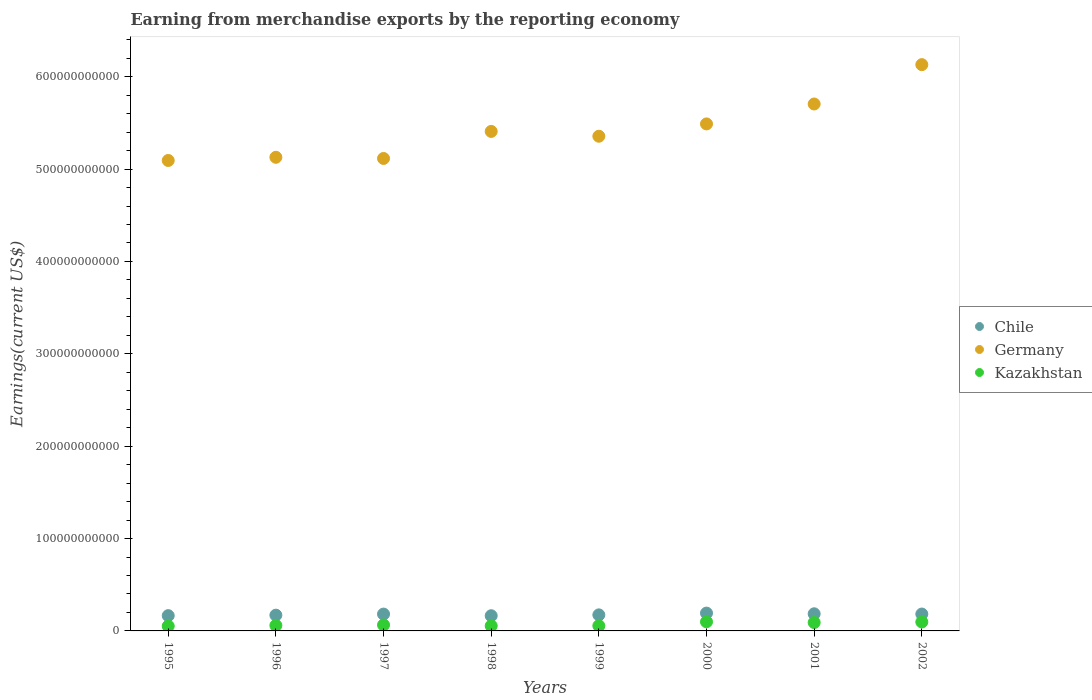How many different coloured dotlines are there?
Your response must be concise. 3. Is the number of dotlines equal to the number of legend labels?
Provide a short and direct response. Yes. What is the amount earned from merchandise exports in Chile in 2001?
Offer a very short reply. 1.86e+1. Across all years, what is the maximum amount earned from merchandise exports in Kazakhstan?
Provide a succinct answer. 9.88e+09. Across all years, what is the minimum amount earned from merchandise exports in Germany?
Give a very brief answer. 5.09e+11. What is the total amount earned from merchandise exports in Kazakhstan in the graph?
Your answer should be very brief. 5.74e+1. What is the difference between the amount earned from merchandise exports in Germany in 1997 and that in 1998?
Ensure brevity in your answer.  -2.93e+1. What is the difference between the amount earned from merchandise exports in Kazakhstan in 1997 and the amount earned from merchandise exports in Chile in 1996?
Provide a succinct answer. -1.06e+1. What is the average amount earned from merchandise exports in Germany per year?
Your answer should be very brief. 5.43e+11. In the year 2002, what is the difference between the amount earned from merchandise exports in Germany and amount earned from merchandise exports in Chile?
Provide a short and direct response. 5.95e+11. What is the ratio of the amount earned from merchandise exports in Kazakhstan in 1996 to that in 1997?
Keep it short and to the point. 0.91. Is the difference between the amount earned from merchandise exports in Germany in 1996 and 2002 greater than the difference between the amount earned from merchandise exports in Chile in 1996 and 2002?
Ensure brevity in your answer.  No. What is the difference between the highest and the second highest amount earned from merchandise exports in Chile?
Your answer should be very brief. 7.41e+08. What is the difference between the highest and the lowest amount earned from merchandise exports in Germany?
Make the answer very short. 1.04e+11. Is the sum of the amount earned from merchandise exports in Chile in 1998 and 2001 greater than the maximum amount earned from merchandise exports in Germany across all years?
Your answer should be compact. No. Is the amount earned from merchandise exports in Chile strictly less than the amount earned from merchandise exports in Kazakhstan over the years?
Your answer should be very brief. No. What is the difference between two consecutive major ticks on the Y-axis?
Offer a very short reply. 1.00e+11. Are the values on the major ticks of Y-axis written in scientific E-notation?
Provide a short and direct response. No. Does the graph contain any zero values?
Your response must be concise. No. Where does the legend appear in the graph?
Offer a very short reply. Center right. How are the legend labels stacked?
Provide a succinct answer. Vertical. What is the title of the graph?
Offer a very short reply. Earning from merchandise exports by the reporting economy. What is the label or title of the Y-axis?
Provide a short and direct response. Earnings(current US$). What is the Earnings(current US$) of Chile in 1995?
Make the answer very short. 1.65e+1. What is the Earnings(current US$) of Germany in 1995?
Provide a succinct answer. 5.09e+11. What is the Earnings(current US$) in Kazakhstan in 1995?
Provide a short and direct response. 5.26e+09. What is the Earnings(current US$) in Chile in 1996?
Offer a terse response. 1.71e+1. What is the Earnings(current US$) of Germany in 1996?
Provide a succinct answer. 5.13e+11. What is the Earnings(current US$) of Kazakhstan in 1996?
Offer a very short reply. 5.93e+09. What is the Earnings(current US$) of Chile in 1997?
Provide a short and direct response. 1.82e+1. What is the Earnings(current US$) of Germany in 1997?
Your response must be concise. 5.11e+11. What is the Earnings(current US$) in Kazakhstan in 1997?
Offer a terse response. 6.50e+09. What is the Earnings(current US$) of Chile in 1998?
Provide a succinct answer. 1.64e+1. What is the Earnings(current US$) of Germany in 1998?
Your answer should be compact. 5.41e+11. What is the Earnings(current US$) in Kazakhstan in 1998?
Give a very brief answer. 5.51e+09. What is the Earnings(current US$) of Chile in 1999?
Your response must be concise. 1.74e+1. What is the Earnings(current US$) in Germany in 1999?
Ensure brevity in your answer.  5.36e+11. What is the Earnings(current US$) of Kazakhstan in 1999?
Provide a short and direct response. 5.60e+09. What is the Earnings(current US$) in Chile in 2000?
Give a very brief answer. 1.93e+1. What is the Earnings(current US$) of Germany in 2000?
Give a very brief answer. 5.49e+11. What is the Earnings(current US$) of Kazakhstan in 2000?
Give a very brief answer. 9.88e+09. What is the Earnings(current US$) of Chile in 2001?
Provide a short and direct response. 1.86e+1. What is the Earnings(current US$) in Germany in 2001?
Offer a very short reply. 5.70e+11. What is the Earnings(current US$) of Kazakhstan in 2001?
Ensure brevity in your answer.  9.09e+09. What is the Earnings(current US$) of Chile in 2002?
Your response must be concise. 1.83e+1. What is the Earnings(current US$) in Germany in 2002?
Offer a terse response. 6.13e+11. What is the Earnings(current US$) of Kazakhstan in 2002?
Offer a terse response. 9.67e+09. Across all years, what is the maximum Earnings(current US$) in Chile?
Your answer should be compact. 1.93e+1. Across all years, what is the maximum Earnings(current US$) of Germany?
Provide a short and direct response. 6.13e+11. Across all years, what is the maximum Earnings(current US$) in Kazakhstan?
Provide a short and direct response. 9.88e+09. Across all years, what is the minimum Earnings(current US$) in Chile?
Keep it short and to the point. 1.64e+1. Across all years, what is the minimum Earnings(current US$) in Germany?
Provide a succinct answer. 5.09e+11. Across all years, what is the minimum Earnings(current US$) in Kazakhstan?
Your answer should be compact. 5.26e+09. What is the total Earnings(current US$) of Chile in the graph?
Your answer should be very brief. 1.42e+11. What is the total Earnings(current US$) of Germany in the graph?
Make the answer very short. 4.34e+12. What is the total Earnings(current US$) of Kazakhstan in the graph?
Keep it short and to the point. 5.74e+1. What is the difference between the Earnings(current US$) in Chile in 1995 and that in 1996?
Make the answer very short. -5.18e+08. What is the difference between the Earnings(current US$) of Germany in 1995 and that in 1996?
Offer a very short reply. -3.45e+09. What is the difference between the Earnings(current US$) in Kazakhstan in 1995 and that in 1996?
Your answer should be compact. -6.70e+08. What is the difference between the Earnings(current US$) in Chile in 1995 and that in 1997?
Your answer should be very brief. -1.68e+09. What is the difference between the Earnings(current US$) in Germany in 1995 and that in 1997?
Your answer should be very brief. -2.18e+09. What is the difference between the Earnings(current US$) of Kazakhstan in 1995 and that in 1997?
Make the answer very short. -1.24e+09. What is the difference between the Earnings(current US$) of Chile in 1995 and that in 1998?
Your answer should be compact. 1.01e+08. What is the difference between the Earnings(current US$) in Germany in 1995 and that in 1998?
Make the answer very short. -3.15e+1. What is the difference between the Earnings(current US$) in Kazakhstan in 1995 and that in 1998?
Give a very brief answer. -2.54e+08. What is the difference between the Earnings(current US$) of Chile in 1995 and that in 1999?
Your answer should be very brief. -8.31e+08. What is the difference between the Earnings(current US$) in Germany in 1995 and that in 1999?
Give a very brief answer. -2.63e+1. What is the difference between the Earnings(current US$) of Kazakhstan in 1995 and that in 1999?
Your answer should be compact. -3.41e+08. What is the difference between the Earnings(current US$) in Chile in 1995 and that in 2000?
Your answer should be compact. -2.75e+09. What is the difference between the Earnings(current US$) of Germany in 1995 and that in 2000?
Ensure brevity in your answer.  -3.96e+1. What is the difference between the Earnings(current US$) in Kazakhstan in 1995 and that in 2000?
Your answer should be compact. -4.62e+09. What is the difference between the Earnings(current US$) in Chile in 1995 and that in 2001?
Offer a terse response. -2.01e+09. What is the difference between the Earnings(current US$) in Germany in 1995 and that in 2001?
Give a very brief answer. -6.11e+1. What is the difference between the Earnings(current US$) of Kazakhstan in 1995 and that in 2001?
Make the answer very short. -3.83e+09. What is the difference between the Earnings(current US$) in Chile in 1995 and that in 2002?
Your response must be concise. -1.74e+09. What is the difference between the Earnings(current US$) in Germany in 1995 and that in 2002?
Your answer should be compact. -1.04e+11. What is the difference between the Earnings(current US$) of Kazakhstan in 1995 and that in 2002?
Provide a succinct answer. -4.41e+09. What is the difference between the Earnings(current US$) of Chile in 1996 and that in 1997?
Keep it short and to the point. -1.16e+09. What is the difference between the Earnings(current US$) of Germany in 1996 and that in 1997?
Your answer should be very brief. 1.27e+09. What is the difference between the Earnings(current US$) in Kazakhstan in 1996 and that in 1997?
Keep it short and to the point. -5.71e+08. What is the difference between the Earnings(current US$) of Chile in 1996 and that in 1998?
Provide a succinct answer. 6.20e+08. What is the difference between the Earnings(current US$) in Germany in 1996 and that in 1998?
Keep it short and to the point. -2.80e+1. What is the difference between the Earnings(current US$) of Kazakhstan in 1996 and that in 1998?
Provide a short and direct response. 4.16e+08. What is the difference between the Earnings(current US$) in Chile in 1996 and that in 1999?
Your response must be concise. -3.13e+08. What is the difference between the Earnings(current US$) of Germany in 1996 and that in 1999?
Provide a short and direct response. -2.28e+1. What is the difference between the Earnings(current US$) of Kazakhstan in 1996 and that in 1999?
Your answer should be compact. 3.28e+08. What is the difference between the Earnings(current US$) in Chile in 1996 and that in 2000?
Provide a succinct answer. -2.23e+09. What is the difference between the Earnings(current US$) of Germany in 1996 and that in 2000?
Offer a very short reply. -3.61e+1. What is the difference between the Earnings(current US$) of Kazakhstan in 1996 and that in 2000?
Provide a short and direct response. -3.95e+09. What is the difference between the Earnings(current US$) in Chile in 1996 and that in 2001?
Offer a terse response. -1.49e+09. What is the difference between the Earnings(current US$) in Germany in 1996 and that in 2001?
Keep it short and to the point. -5.77e+1. What is the difference between the Earnings(current US$) of Kazakhstan in 1996 and that in 2001?
Offer a very short reply. -3.16e+09. What is the difference between the Earnings(current US$) of Chile in 1996 and that in 2002?
Keep it short and to the point. -1.22e+09. What is the difference between the Earnings(current US$) in Germany in 1996 and that in 2002?
Offer a very short reply. -1.00e+11. What is the difference between the Earnings(current US$) in Kazakhstan in 1996 and that in 2002?
Provide a succinct answer. -3.74e+09. What is the difference between the Earnings(current US$) in Chile in 1997 and that in 1998?
Provide a succinct answer. 1.78e+09. What is the difference between the Earnings(current US$) in Germany in 1997 and that in 1998?
Make the answer very short. -2.93e+1. What is the difference between the Earnings(current US$) of Kazakhstan in 1997 and that in 1998?
Make the answer very short. 9.87e+08. What is the difference between the Earnings(current US$) of Chile in 1997 and that in 1999?
Offer a very short reply. 8.47e+08. What is the difference between the Earnings(current US$) in Germany in 1997 and that in 1999?
Offer a very short reply. -2.41e+1. What is the difference between the Earnings(current US$) in Kazakhstan in 1997 and that in 1999?
Keep it short and to the point. 8.99e+08. What is the difference between the Earnings(current US$) of Chile in 1997 and that in 2000?
Offer a terse response. -1.07e+09. What is the difference between the Earnings(current US$) of Germany in 1997 and that in 2000?
Your answer should be compact. -3.74e+1. What is the difference between the Earnings(current US$) of Kazakhstan in 1997 and that in 2000?
Offer a terse response. -3.38e+09. What is the difference between the Earnings(current US$) of Chile in 1997 and that in 2001?
Your answer should be very brief. -3.32e+08. What is the difference between the Earnings(current US$) in Germany in 1997 and that in 2001?
Give a very brief answer. -5.90e+1. What is the difference between the Earnings(current US$) of Kazakhstan in 1997 and that in 2001?
Provide a short and direct response. -2.59e+09. What is the difference between the Earnings(current US$) in Chile in 1997 and that in 2002?
Provide a succinct answer. -6.26e+07. What is the difference between the Earnings(current US$) of Germany in 1997 and that in 2002?
Provide a succinct answer. -1.02e+11. What is the difference between the Earnings(current US$) in Kazakhstan in 1997 and that in 2002?
Your answer should be compact. -3.17e+09. What is the difference between the Earnings(current US$) of Chile in 1998 and that in 1999?
Provide a succinct answer. -9.33e+08. What is the difference between the Earnings(current US$) in Germany in 1998 and that in 1999?
Ensure brevity in your answer.  5.21e+09. What is the difference between the Earnings(current US$) in Kazakhstan in 1998 and that in 1999?
Your answer should be very brief. -8.72e+07. What is the difference between the Earnings(current US$) of Chile in 1998 and that in 2000?
Ensure brevity in your answer.  -2.85e+09. What is the difference between the Earnings(current US$) of Germany in 1998 and that in 2000?
Your response must be concise. -8.13e+09. What is the difference between the Earnings(current US$) in Kazakhstan in 1998 and that in 2000?
Your answer should be very brief. -4.37e+09. What is the difference between the Earnings(current US$) in Chile in 1998 and that in 2001?
Ensure brevity in your answer.  -2.11e+09. What is the difference between the Earnings(current US$) in Germany in 1998 and that in 2001?
Ensure brevity in your answer.  -2.97e+1. What is the difference between the Earnings(current US$) in Kazakhstan in 1998 and that in 2001?
Your response must be concise. -3.57e+09. What is the difference between the Earnings(current US$) of Chile in 1998 and that in 2002?
Provide a short and direct response. -1.84e+09. What is the difference between the Earnings(current US$) in Germany in 1998 and that in 2002?
Your response must be concise. -7.23e+1. What is the difference between the Earnings(current US$) of Kazakhstan in 1998 and that in 2002?
Give a very brief answer. -4.16e+09. What is the difference between the Earnings(current US$) of Chile in 1999 and that in 2000?
Your response must be concise. -1.92e+09. What is the difference between the Earnings(current US$) in Germany in 1999 and that in 2000?
Your answer should be compact. -1.33e+1. What is the difference between the Earnings(current US$) of Kazakhstan in 1999 and that in 2000?
Your answer should be compact. -4.28e+09. What is the difference between the Earnings(current US$) of Chile in 1999 and that in 2001?
Keep it short and to the point. -1.18e+09. What is the difference between the Earnings(current US$) of Germany in 1999 and that in 2001?
Provide a succinct answer. -3.49e+1. What is the difference between the Earnings(current US$) in Kazakhstan in 1999 and that in 2001?
Your response must be concise. -3.49e+09. What is the difference between the Earnings(current US$) of Chile in 1999 and that in 2002?
Ensure brevity in your answer.  -9.09e+08. What is the difference between the Earnings(current US$) of Germany in 1999 and that in 2002?
Provide a short and direct response. -7.75e+1. What is the difference between the Earnings(current US$) in Kazakhstan in 1999 and that in 2002?
Provide a succinct answer. -4.07e+09. What is the difference between the Earnings(current US$) in Chile in 2000 and that in 2001?
Give a very brief answer. 7.41e+08. What is the difference between the Earnings(current US$) in Germany in 2000 and that in 2001?
Offer a terse response. -2.16e+1. What is the difference between the Earnings(current US$) in Kazakhstan in 2000 and that in 2001?
Make the answer very short. 7.95e+08. What is the difference between the Earnings(current US$) in Chile in 2000 and that in 2002?
Make the answer very short. 1.01e+09. What is the difference between the Earnings(current US$) in Germany in 2000 and that in 2002?
Ensure brevity in your answer.  -6.42e+1. What is the difference between the Earnings(current US$) in Kazakhstan in 2000 and that in 2002?
Provide a short and direct response. 2.09e+08. What is the difference between the Earnings(current US$) in Chile in 2001 and that in 2002?
Offer a very short reply. 2.69e+08. What is the difference between the Earnings(current US$) of Germany in 2001 and that in 2002?
Give a very brief answer. -4.26e+1. What is the difference between the Earnings(current US$) in Kazakhstan in 2001 and that in 2002?
Your answer should be very brief. -5.85e+08. What is the difference between the Earnings(current US$) of Chile in 1995 and the Earnings(current US$) of Germany in 1996?
Keep it short and to the point. -4.96e+11. What is the difference between the Earnings(current US$) in Chile in 1995 and the Earnings(current US$) in Kazakhstan in 1996?
Ensure brevity in your answer.  1.06e+1. What is the difference between the Earnings(current US$) in Germany in 1995 and the Earnings(current US$) in Kazakhstan in 1996?
Provide a short and direct response. 5.03e+11. What is the difference between the Earnings(current US$) of Chile in 1995 and the Earnings(current US$) of Germany in 1997?
Your answer should be very brief. -4.95e+11. What is the difference between the Earnings(current US$) of Chile in 1995 and the Earnings(current US$) of Kazakhstan in 1997?
Offer a terse response. 1.00e+1. What is the difference between the Earnings(current US$) in Germany in 1995 and the Earnings(current US$) in Kazakhstan in 1997?
Provide a short and direct response. 5.03e+11. What is the difference between the Earnings(current US$) of Chile in 1995 and the Earnings(current US$) of Germany in 1998?
Offer a terse response. -5.24e+11. What is the difference between the Earnings(current US$) in Chile in 1995 and the Earnings(current US$) in Kazakhstan in 1998?
Offer a very short reply. 1.10e+1. What is the difference between the Earnings(current US$) of Germany in 1995 and the Earnings(current US$) of Kazakhstan in 1998?
Your answer should be very brief. 5.04e+11. What is the difference between the Earnings(current US$) in Chile in 1995 and the Earnings(current US$) in Germany in 1999?
Offer a very short reply. -5.19e+11. What is the difference between the Earnings(current US$) of Chile in 1995 and the Earnings(current US$) of Kazakhstan in 1999?
Provide a succinct answer. 1.09e+1. What is the difference between the Earnings(current US$) in Germany in 1995 and the Earnings(current US$) in Kazakhstan in 1999?
Make the answer very short. 5.04e+11. What is the difference between the Earnings(current US$) in Chile in 1995 and the Earnings(current US$) in Germany in 2000?
Your answer should be compact. -5.32e+11. What is the difference between the Earnings(current US$) in Chile in 1995 and the Earnings(current US$) in Kazakhstan in 2000?
Make the answer very short. 6.66e+09. What is the difference between the Earnings(current US$) in Germany in 1995 and the Earnings(current US$) in Kazakhstan in 2000?
Ensure brevity in your answer.  4.99e+11. What is the difference between the Earnings(current US$) of Chile in 1995 and the Earnings(current US$) of Germany in 2001?
Provide a succinct answer. -5.54e+11. What is the difference between the Earnings(current US$) of Chile in 1995 and the Earnings(current US$) of Kazakhstan in 2001?
Make the answer very short. 7.46e+09. What is the difference between the Earnings(current US$) in Germany in 1995 and the Earnings(current US$) in Kazakhstan in 2001?
Give a very brief answer. 5.00e+11. What is the difference between the Earnings(current US$) in Chile in 1995 and the Earnings(current US$) in Germany in 2002?
Your response must be concise. -5.97e+11. What is the difference between the Earnings(current US$) of Chile in 1995 and the Earnings(current US$) of Kazakhstan in 2002?
Keep it short and to the point. 6.87e+09. What is the difference between the Earnings(current US$) of Germany in 1995 and the Earnings(current US$) of Kazakhstan in 2002?
Your answer should be very brief. 5.00e+11. What is the difference between the Earnings(current US$) in Chile in 1996 and the Earnings(current US$) in Germany in 1997?
Provide a short and direct response. -4.94e+11. What is the difference between the Earnings(current US$) in Chile in 1996 and the Earnings(current US$) in Kazakhstan in 1997?
Offer a terse response. 1.06e+1. What is the difference between the Earnings(current US$) in Germany in 1996 and the Earnings(current US$) in Kazakhstan in 1997?
Give a very brief answer. 5.06e+11. What is the difference between the Earnings(current US$) in Chile in 1996 and the Earnings(current US$) in Germany in 1998?
Keep it short and to the point. -5.24e+11. What is the difference between the Earnings(current US$) of Chile in 1996 and the Earnings(current US$) of Kazakhstan in 1998?
Make the answer very short. 1.16e+1. What is the difference between the Earnings(current US$) of Germany in 1996 and the Earnings(current US$) of Kazakhstan in 1998?
Ensure brevity in your answer.  5.07e+11. What is the difference between the Earnings(current US$) in Chile in 1996 and the Earnings(current US$) in Germany in 1999?
Your response must be concise. -5.18e+11. What is the difference between the Earnings(current US$) in Chile in 1996 and the Earnings(current US$) in Kazakhstan in 1999?
Ensure brevity in your answer.  1.15e+1. What is the difference between the Earnings(current US$) of Germany in 1996 and the Earnings(current US$) of Kazakhstan in 1999?
Offer a terse response. 5.07e+11. What is the difference between the Earnings(current US$) in Chile in 1996 and the Earnings(current US$) in Germany in 2000?
Keep it short and to the point. -5.32e+11. What is the difference between the Earnings(current US$) in Chile in 1996 and the Earnings(current US$) in Kazakhstan in 2000?
Make the answer very short. 7.18e+09. What is the difference between the Earnings(current US$) in Germany in 1996 and the Earnings(current US$) in Kazakhstan in 2000?
Your answer should be compact. 5.03e+11. What is the difference between the Earnings(current US$) in Chile in 1996 and the Earnings(current US$) in Germany in 2001?
Make the answer very short. -5.53e+11. What is the difference between the Earnings(current US$) in Chile in 1996 and the Earnings(current US$) in Kazakhstan in 2001?
Offer a terse response. 7.98e+09. What is the difference between the Earnings(current US$) of Germany in 1996 and the Earnings(current US$) of Kazakhstan in 2001?
Ensure brevity in your answer.  5.04e+11. What is the difference between the Earnings(current US$) in Chile in 1996 and the Earnings(current US$) in Germany in 2002?
Provide a succinct answer. -5.96e+11. What is the difference between the Earnings(current US$) in Chile in 1996 and the Earnings(current US$) in Kazakhstan in 2002?
Your response must be concise. 7.39e+09. What is the difference between the Earnings(current US$) in Germany in 1996 and the Earnings(current US$) in Kazakhstan in 2002?
Offer a terse response. 5.03e+11. What is the difference between the Earnings(current US$) of Chile in 1997 and the Earnings(current US$) of Germany in 1998?
Offer a terse response. -5.23e+11. What is the difference between the Earnings(current US$) of Chile in 1997 and the Earnings(current US$) of Kazakhstan in 1998?
Provide a short and direct response. 1.27e+1. What is the difference between the Earnings(current US$) of Germany in 1997 and the Earnings(current US$) of Kazakhstan in 1998?
Offer a very short reply. 5.06e+11. What is the difference between the Earnings(current US$) in Chile in 1997 and the Earnings(current US$) in Germany in 1999?
Provide a succinct answer. -5.17e+11. What is the difference between the Earnings(current US$) in Chile in 1997 and the Earnings(current US$) in Kazakhstan in 1999?
Your answer should be compact. 1.26e+1. What is the difference between the Earnings(current US$) of Germany in 1997 and the Earnings(current US$) of Kazakhstan in 1999?
Offer a very short reply. 5.06e+11. What is the difference between the Earnings(current US$) of Chile in 1997 and the Earnings(current US$) of Germany in 2000?
Keep it short and to the point. -5.31e+11. What is the difference between the Earnings(current US$) in Chile in 1997 and the Earnings(current US$) in Kazakhstan in 2000?
Your answer should be compact. 8.34e+09. What is the difference between the Earnings(current US$) of Germany in 1997 and the Earnings(current US$) of Kazakhstan in 2000?
Keep it short and to the point. 5.02e+11. What is the difference between the Earnings(current US$) of Chile in 1997 and the Earnings(current US$) of Germany in 2001?
Provide a short and direct response. -5.52e+11. What is the difference between the Earnings(current US$) in Chile in 1997 and the Earnings(current US$) in Kazakhstan in 2001?
Provide a short and direct response. 9.14e+09. What is the difference between the Earnings(current US$) in Germany in 1997 and the Earnings(current US$) in Kazakhstan in 2001?
Provide a short and direct response. 5.02e+11. What is the difference between the Earnings(current US$) of Chile in 1997 and the Earnings(current US$) of Germany in 2002?
Make the answer very short. -5.95e+11. What is the difference between the Earnings(current US$) of Chile in 1997 and the Earnings(current US$) of Kazakhstan in 2002?
Your answer should be very brief. 8.55e+09. What is the difference between the Earnings(current US$) in Germany in 1997 and the Earnings(current US$) in Kazakhstan in 2002?
Make the answer very short. 5.02e+11. What is the difference between the Earnings(current US$) of Chile in 1998 and the Earnings(current US$) of Germany in 1999?
Provide a short and direct response. -5.19e+11. What is the difference between the Earnings(current US$) of Chile in 1998 and the Earnings(current US$) of Kazakhstan in 1999?
Make the answer very short. 1.08e+1. What is the difference between the Earnings(current US$) of Germany in 1998 and the Earnings(current US$) of Kazakhstan in 1999?
Provide a short and direct response. 5.35e+11. What is the difference between the Earnings(current US$) of Chile in 1998 and the Earnings(current US$) of Germany in 2000?
Provide a short and direct response. -5.32e+11. What is the difference between the Earnings(current US$) in Chile in 1998 and the Earnings(current US$) in Kazakhstan in 2000?
Your answer should be very brief. 6.56e+09. What is the difference between the Earnings(current US$) in Germany in 1998 and the Earnings(current US$) in Kazakhstan in 2000?
Keep it short and to the point. 5.31e+11. What is the difference between the Earnings(current US$) of Chile in 1998 and the Earnings(current US$) of Germany in 2001?
Keep it short and to the point. -5.54e+11. What is the difference between the Earnings(current US$) of Chile in 1998 and the Earnings(current US$) of Kazakhstan in 2001?
Keep it short and to the point. 7.36e+09. What is the difference between the Earnings(current US$) in Germany in 1998 and the Earnings(current US$) in Kazakhstan in 2001?
Keep it short and to the point. 5.32e+11. What is the difference between the Earnings(current US$) in Chile in 1998 and the Earnings(current US$) in Germany in 2002?
Offer a very short reply. -5.97e+11. What is the difference between the Earnings(current US$) in Chile in 1998 and the Earnings(current US$) in Kazakhstan in 2002?
Ensure brevity in your answer.  6.77e+09. What is the difference between the Earnings(current US$) in Germany in 1998 and the Earnings(current US$) in Kazakhstan in 2002?
Keep it short and to the point. 5.31e+11. What is the difference between the Earnings(current US$) in Chile in 1999 and the Earnings(current US$) in Germany in 2000?
Ensure brevity in your answer.  -5.32e+11. What is the difference between the Earnings(current US$) in Chile in 1999 and the Earnings(current US$) in Kazakhstan in 2000?
Give a very brief answer. 7.50e+09. What is the difference between the Earnings(current US$) of Germany in 1999 and the Earnings(current US$) of Kazakhstan in 2000?
Offer a terse response. 5.26e+11. What is the difference between the Earnings(current US$) of Chile in 1999 and the Earnings(current US$) of Germany in 2001?
Provide a succinct answer. -5.53e+11. What is the difference between the Earnings(current US$) of Chile in 1999 and the Earnings(current US$) of Kazakhstan in 2001?
Make the answer very short. 8.29e+09. What is the difference between the Earnings(current US$) of Germany in 1999 and the Earnings(current US$) of Kazakhstan in 2001?
Ensure brevity in your answer.  5.26e+11. What is the difference between the Earnings(current US$) of Chile in 1999 and the Earnings(current US$) of Germany in 2002?
Provide a succinct answer. -5.96e+11. What is the difference between the Earnings(current US$) of Chile in 1999 and the Earnings(current US$) of Kazakhstan in 2002?
Your answer should be compact. 7.71e+09. What is the difference between the Earnings(current US$) in Germany in 1999 and the Earnings(current US$) in Kazakhstan in 2002?
Make the answer very short. 5.26e+11. What is the difference between the Earnings(current US$) in Chile in 2000 and the Earnings(current US$) in Germany in 2001?
Ensure brevity in your answer.  -5.51e+11. What is the difference between the Earnings(current US$) in Chile in 2000 and the Earnings(current US$) in Kazakhstan in 2001?
Provide a succinct answer. 1.02e+1. What is the difference between the Earnings(current US$) in Germany in 2000 and the Earnings(current US$) in Kazakhstan in 2001?
Make the answer very short. 5.40e+11. What is the difference between the Earnings(current US$) in Chile in 2000 and the Earnings(current US$) in Germany in 2002?
Give a very brief answer. -5.94e+11. What is the difference between the Earnings(current US$) of Chile in 2000 and the Earnings(current US$) of Kazakhstan in 2002?
Offer a very short reply. 9.63e+09. What is the difference between the Earnings(current US$) in Germany in 2000 and the Earnings(current US$) in Kazakhstan in 2002?
Offer a very short reply. 5.39e+11. What is the difference between the Earnings(current US$) in Chile in 2001 and the Earnings(current US$) in Germany in 2002?
Offer a terse response. -5.95e+11. What is the difference between the Earnings(current US$) of Chile in 2001 and the Earnings(current US$) of Kazakhstan in 2002?
Your answer should be compact. 8.88e+09. What is the difference between the Earnings(current US$) of Germany in 2001 and the Earnings(current US$) of Kazakhstan in 2002?
Make the answer very short. 5.61e+11. What is the average Earnings(current US$) of Chile per year?
Keep it short and to the point. 1.77e+1. What is the average Earnings(current US$) of Germany per year?
Your response must be concise. 5.43e+11. What is the average Earnings(current US$) of Kazakhstan per year?
Provide a succinct answer. 7.18e+09. In the year 1995, what is the difference between the Earnings(current US$) of Chile and Earnings(current US$) of Germany?
Your answer should be very brief. -4.93e+11. In the year 1995, what is the difference between the Earnings(current US$) of Chile and Earnings(current US$) of Kazakhstan?
Offer a very short reply. 1.13e+1. In the year 1995, what is the difference between the Earnings(current US$) in Germany and Earnings(current US$) in Kazakhstan?
Your answer should be compact. 5.04e+11. In the year 1996, what is the difference between the Earnings(current US$) of Chile and Earnings(current US$) of Germany?
Provide a succinct answer. -4.96e+11. In the year 1996, what is the difference between the Earnings(current US$) in Chile and Earnings(current US$) in Kazakhstan?
Your response must be concise. 1.11e+1. In the year 1996, what is the difference between the Earnings(current US$) of Germany and Earnings(current US$) of Kazakhstan?
Provide a short and direct response. 5.07e+11. In the year 1997, what is the difference between the Earnings(current US$) in Chile and Earnings(current US$) in Germany?
Your response must be concise. -4.93e+11. In the year 1997, what is the difference between the Earnings(current US$) of Chile and Earnings(current US$) of Kazakhstan?
Your answer should be very brief. 1.17e+1. In the year 1997, what is the difference between the Earnings(current US$) of Germany and Earnings(current US$) of Kazakhstan?
Your response must be concise. 5.05e+11. In the year 1998, what is the difference between the Earnings(current US$) of Chile and Earnings(current US$) of Germany?
Offer a very short reply. -5.24e+11. In the year 1998, what is the difference between the Earnings(current US$) in Chile and Earnings(current US$) in Kazakhstan?
Offer a terse response. 1.09e+1. In the year 1998, what is the difference between the Earnings(current US$) in Germany and Earnings(current US$) in Kazakhstan?
Keep it short and to the point. 5.35e+11. In the year 1999, what is the difference between the Earnings(current US$) in Chile and Earnings(current US$) in Germany?
Give a very brief answer. -5.18e+11. In the year 1999, what is the difference between the Earnings(current US$) of Chile and Earnings(current US$) of Kazakhstan?
Your answer should be compact. 1.18e+1. In the year 1999, what is the difference between the Earnings(current US$) of Germany and Earnings(current US$) of Kazakhstan?
Give a very brief answer. 5.30e+11. In the year 2000, what is the difference between the Earnings(current US$) of Chile and Earnings(current US$) of Germany?
Your answer should be compact. -5.30e+11. In the year 2000, what is the difference between the Earnings(current US$) of Chile and Earnings(current US$) of Kazakhstan?
Provide a succinct answer. 9.42e+09. In the year 2000, what is the difference between the Earnings(current US$) of Germany and Earnings(current US$) of Kazakhstan?
Your response must be concise. 5.39e+11. In the year 2001, what is the difference between the Earnings(current US$) of Chile and Earnings(current US$) of Germany?
Your answer should be very brief. -5.52e+11. In the year 2001, what is the difference between the Earnings(current US$) of Chile and Earnings(current US$) of Kazakhstan?
Provide a succinct answer. 9.47e+09. In the year 2001, what is the difference between the Earnings(current US$) of Germany and Earnings(current US$) of Kazakhstan?
Provide a succinct answer. 5.61e+11. In the year 2002, what is the difference between the Earnings(current US$) in Chile and Earnings(current US$) in Germany?
Keep it short and to the point. -5.95e+11. In the year 2002, what is the difference between the Earnings(current US$) of Chile and Earnings(current US$) of Kazakhstan?
Keep it short and to the point. 8.61e+09. In the year 2002, what is the difference between the Earnings(current US$) of Germany and Earnings(current US$) of Kazakhstan?
Offer a very short reply. 6.03e+11. What is the ratio of the Earnings(current US$) of Chile in 1995 to that in 1996?
Provide a succinct answer. 0.97. What is the ratio of the Earnings(current US$) in Germany in 1995 to that in 1996?
Ensure brevity in your answer.  0.99. What is the ratio of the Earnings(current US$) in Kazakhstan in 1995 to that in 1996?
Your answer should be very brief. 0.89. What is the ratio of the Earnings(current US$) in Chile in 1995 to that in 1997?
Provide a short and direct response. 0.91. What is the ratio of the Earnings(current US$) in Kazakhstan in 1995 to that in 1997?
Provide a short and direct response. 0.81. What is the ratio of the Earnings(current US$) of Chile in 1995 to that in 1998?
Offer a very short reply. 1.01. What is the ratio of the Earnings(current US$) of Germany in 1995 to that in 1998?
Provide a short and direct response. 0.94. What is the ratio of the Earnings(current US$) in Kazakhstan in 1995 to that in 1998?
Provide a succinct answer. 0.95. What is the ratio of the Earnings(current US$) in Chile in 1995 to that in 1999?
Your answer should be very brief. 0.95. What is the ratio of the Earnings(current US$) in Germany in 1995 to that in 1999?
Provide a succinct answer. 0.95. What is the ratio of the Earnings(current US$) in Kazakhstan in 1995 to that in 1999?
Keep it short and to the point. 0.94. What is the ratio of the Earnings(current US$) of Chile in 1995 to that in 2000?
Offer a terse response. 0.86. What is the ratio of the Earnings(current US$) of Germany in 1995 to that in 2000?
Your answer should be very brief. 0.93. What is the ratio of the Earnings(current US$) of Kazakhstan in 1995 to that in 2000?
Give a very brief answer. 0.53. What is the ratio of the Earnings(current US$) of Chile in 1995 to that in 2001?
Your answer should be compact. 0.89. What is the ratio of the Earnings(current US$) of Germany in 1995 to that in 2001?
Offer a terse response. 0.89. What is the ratio of the Earnings(current US$) of Kazakhstan in 1995 to that in 2001?
Give a very brief answer. 0.58. What is the ratio of the Earnings(current US$) of Chile in 1995 to that in 2002?
Ensure brevity in your answer.  0.9. What is the ratio of the Earnings(current US$) in Germany in 1995 to that in 2002?
Offer a terse response. 0.83. What is the ratio of the Earnings(current US$) of Kazakhstan in 1995 to that in 2002?
Your answer should be very brief. 0.54. What is the ratio of the Earnings(current US$) in Chile in 1996 to that in 1997?
Give a very brief answer. 0.94. What is the ratio of the Earnings(current US$) in Kazakhstan in 1996 to that in 1997?
Your response must be concise. 0.91. What is the ratio of the Earnings(current US$) in Chile in 1996 to that in 1998?
Give a very brief answer. 1.04. What is the ratio of the Earnings(current US$) in Germany in 1996 to that in 1998?
Make the answer very short. 0.95. What is the ratio of the Earnings(current US$) in Kazakhstan in 1996 to that in 1998?
Offer a very short reply. 1.08. What is the ratio of the Earnings(current US$) of Germany in 1996 to that in 1999?
Your answer should be very brief. 0.96. What is the ratio of the Earnings(current US$) of Kazakhstan in 1996 to that in 1999?
Your answer should be compact. 1.06. What is the ratio of the Earnings(current US$) of Chile in 1996 to that in 2000?
Ensure brevity in your answer.  0.88. What is the ratio of the Earnings(current US$) in Germany in 1996 to that in 2000?
Offer a very short reply. 0.93. What is the ratio of the Earnings(current US$) in Kazakhstan in 1996 to that in 2000?
Provide a succinct answer. 0.6. What is the ratio of the Earnings(current US$) in Chile in 1996 to that in 2001?
Provide a short and direct response. 0.92. What is the ratio of the Earnings(current US$) of Germany in 1996 to that in 2001?
Give a very brief answer. 0.9. What is the ratio of the Earnings(current US$) of Kazakhstan in 1996 to that in 2001?
Offer a terse response. 0.65. What is the ratio of the Earnings(current US$) in Chile in 1996 to that in 2002?
Make the answer very short. 0.93. What is the ratio of the Earnings(current US$) in Germany in 1996 to that in 2002?
Your answer should be very brief. 0.84. What is the ratio of the Earnings(current US$) of Kazakhstan in 1996 to that in 2002?
Make the answer very short. 0.61. What is the ratio of the Earnings(current US$) of Chile in 1997 to that in 1998?
Your answer should be compact. 1.11. What is the ratio of the Earnings(current US$) in Germany in 1997 to that in 1998?
Ensure brevity in your answer.  0.95. What is the ratio of the Earnings(current US$) of Kazakhstan in 1997 to that in 1998?
Provide a short and direct response. 1.18. What is the ratio of the Earnings(current US$) of Chile in 1997 to that in 1999?
Ensure brevity in your answer.  1.05. What is the ratio of the Earnings(current US$) in Germany in 1997 to that in 1999?
Your answer should be compact. 0.96. What is the ratio of the Earnings(current US$) in Kazakhstan in 1997 to that in 1999?
Keep it short and to the point. 1.16. What is the ratio of the Earnings(current US$) in Chile in 1997 to that in 2000?
Your response must be concise. 0.94. What is the ratio of the Earnings(current US$) of Germany in 1997 to that in 2000?
Your answer should be compact. 0.93. What is the ratio of the Earnings(current US$) in Kazakhstan in 1997 to that in 2000?
Your answer should be very brief. 0.66. What is the ratio of the Earnings(current US$) in Chile in 1997 to that in 2001?
Keep it short and to the point. 0.98. What is the ratio of the Earnings(current US$) of Germany in 1997 to that in 2001?
Your answer should be very brief. 0.9. What is the ratio of the Earnings(current US$) in Kazakhstan in 1997 to that in 2001?
Your answer should be very brief. 0.72. What is the ratio of the Earnings(current US$) in Chile in 1997 to that in 2002?
Ensure brevity in your answer.  1. What is the ratio of the Earnings(current US$) of Germany in 1997 to that in 2002?
Make the answer very short. 0.83. What is the ratio of the Earnings(current US$) in Kazakhstan in 1997 to that in 2002?
Provide a short and direct response. 0.67. What is the ratio of the Earnings(current US$) in Chile in 1998 to that in 1999?
Give a very brief answer. 0.95. What is the ratio of the Earnings(current US$) of Germany in 1998 to that in 1999?
Provide a succinct answer. 1.01. What is the ratio of the Earnings(current US$) of Kazakhstan in 1998 to that in 1999?
Provide a succinct answer. 0.98. What is the ratio of the Earnings(current US$) of Chile in 1998 to that in 2000?
Offer a very short reply. 0.85. What is the ratio of the Earnings(current US$) of Germany in 1998 to that in 2000?
Provide a succinct answer. 0.99. What is the ratio of the Earnings(current US$) of Kazakhstan in 1998 to that in 2000?
Ensure brevity in your answer.  0.56. What is the ratio of the Earnings(current US$) of Chile in 1998 to that in 2001?
Your answer should be very brief. 0.89. What is the ratio of the Earnings(current US$) of Germany in 1998 to that in 2001?
Offer a terse response. 0.95. What is the ratio of the Earnings(current US$) in Kazakhstan in 1998 to that in 2001?
Ensure brevity in your answer.  0.61. What is the ratio of the Earnings(current US$) in Chile in 1998 to that in 2002?
Provide a short and direct response. 0.9. What is the ratio of the Earnings(current US$) of Germany in 1998 to that in 2002?
Provide a succinct answer. 0.88. What is the ratio of the Earnings(current US$) of Kazakhstan in 1998 to that in 2002?
Your response must be concise. 0.57. What is the ratio of the Earnings(current US$) in Chile in 1999 to that in 2000?
Offer a terse response. 0.9. What is the ratio of the Earnings(current US$) of Germany in 1999 to that in 2000?
Offer a very short reply. 0.98. What is the ratio of the Earnings(current US$) in Kazakhstan in 1999 to that in 2000?
Provide a succinct answer. 0.57. What is the ratio of the Earnings(current US$) of Chile in 1999 to that in 2001?
Offer a terse response. 0.94. What is the ratio of the Earnings(current US$) of Germany in 1999 to that in 2001?
Provide a short and direct response. 0.94. What is the ratio of the Earnings(current US$) in Kazakhstan in 1999 to that in 2001?
Your response must be concise. 0.62. What is the ratio of the Earnings(current US$) of Chile in 1999 to that in 2002?
Your answer should be very brief. 0.95. What is the ratio of the Earnings(current US$) in Germany in 1999 to that in 2002?
Give a very brief answer. 0.87. What is the ratio of the Earnings(current US$) of Kazakhstan in 1999 to that in 2002?
Give a very brief answer. 0.58. What is the ratio of the Earnings(current US$) in Germany in 2000 to that in 2001?
Make the answer very short. 0.96. What is the ratio of the Earnings(current US$) of Kazakhstan in 2000 to that in 2001?
Ensure brevity in your answer.  1.09. What is the ratio of the Earnings(current US$) in Chile in 2000 to that in 2002?
Your answer should be compact. 1.06. What is the ratio of the Earnings(current US$) in Germany in 2000 to that in 2002?
Keep it short and to the point. 0.9. What is the ratio of the Earnings(current US$) of Kazakhstan in 2000 to that in 2002?
Keep it short and to the point. 1.02. What is the ratio of the Earnings(current US$) in Chile in 2001 to that in 2002?
Provide a short and direct response. 1.01. What is the ratio of the Earnings(current US$) of Germany in 2001 to that in 2002?
Ensure brevity in your answer.  0.93. What is the ratio of the Earnings(current US$) in Kazakhstan in 2001 to that in 2002?
Make the answer very short. 0.94. What is the difference between the highest and the second highest Earnings(current US$) in Chile?
Your answer should be very brief. 7.41e+08. What is the difference between the highest and the second highest Earnings(current US$) in Germany?
Offer a very short reply. 4.26e+1. What is the difference between the highest and the second highest Earnings(current US$) in Kazakhstan?
Your response must be concise. 2.09e+08. What is the difference between the highest and the lowest Earnings(current US$) in Chile?
Provide a short and direct response. 2.85e+09. What is the difference between the highest and the lowest Earnings(current US$) in Germany?
Provide a short and direct response. 1.04e+11. What is the difference between the highest and the lowest Earnings(current US$) in Kazakhstan?
Your answer should be compact. 4.62e+09. 